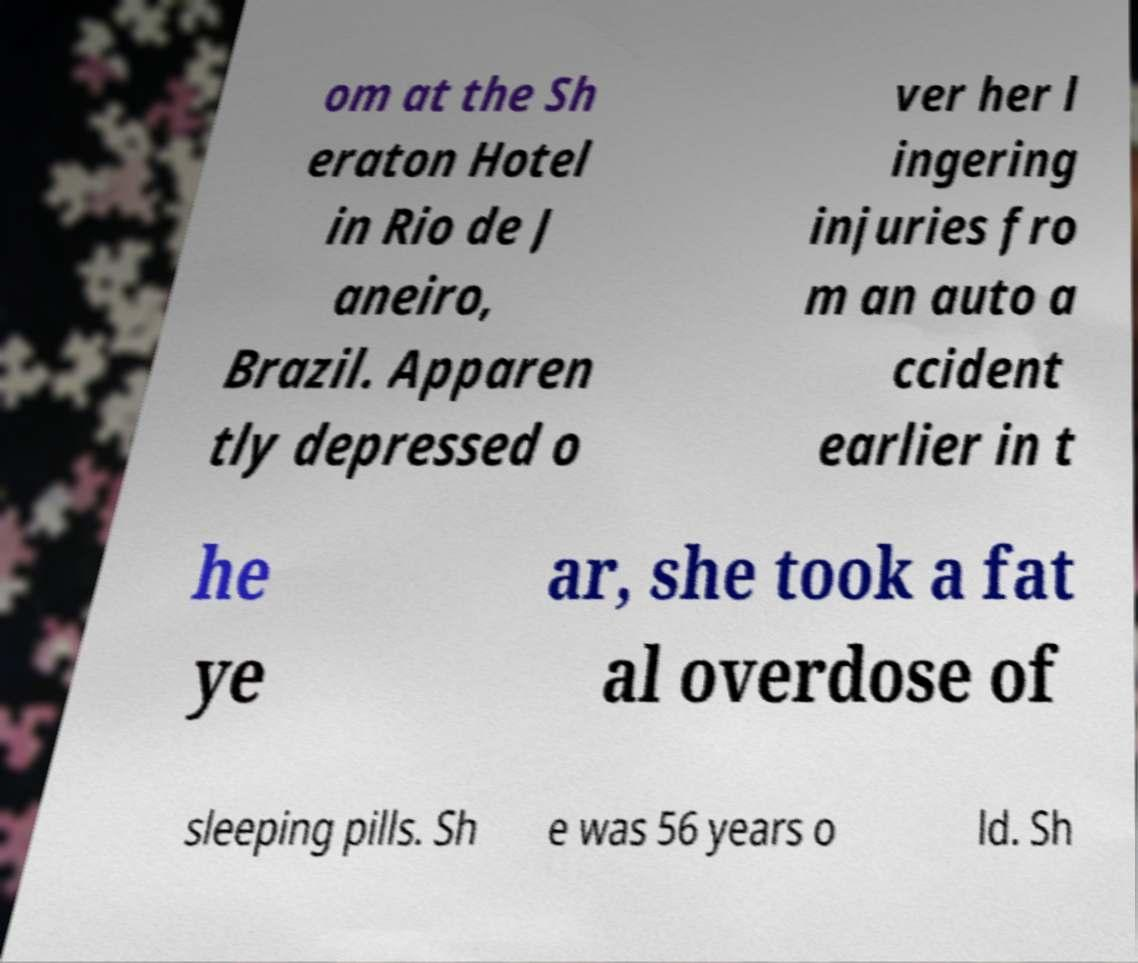What messages or text are displayed in this image? I need them in a readable, typed format. om at the Sh eraton Hotel in Rio de J aneiro, Brazil. Apparen tly depressed o ver her l ingering injuries fro m an auto a ccident earlier in t he ye ar, she took a fat al overdose of sleeping pills. Sh e was 56 years o ld. Sh 